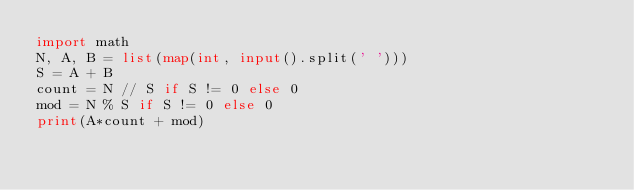Convert code to text. <code><loc_0><loc_0><loc_500><loc_500><_Python_>import math
N, A, B = list(map(int, input().split(' ')))
S = A + B
count = N // S if S != 0 else 0
mod = N % S if S != 0 else 0
print(A*count + mod)
</code> 